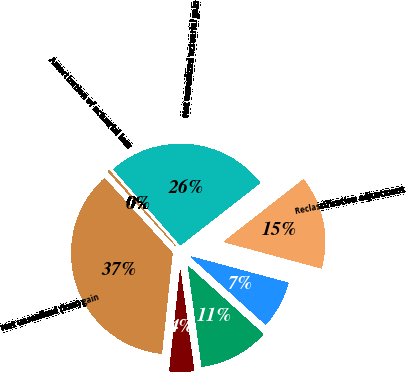Convert chart. <chart><loc_0><loc_0><loc_500><loc_500><pie_chart><fcel>Net unrealized gain (loss)<fcel>Income tax effect<fcel>Reclassification adjustment<fcel>Net unrealized actuarial gain<fcel>Amortization of actuarial loss<fcel>Net unrealized (loss) gain<fcel>Foreign currency translation<nl><fcel>11.13%<fcel>7.49%<fcel>14.77%<fcel>25.96%<fcel>0.21%<fcel>36.6%<fcel>3.85%<nl></chart> 